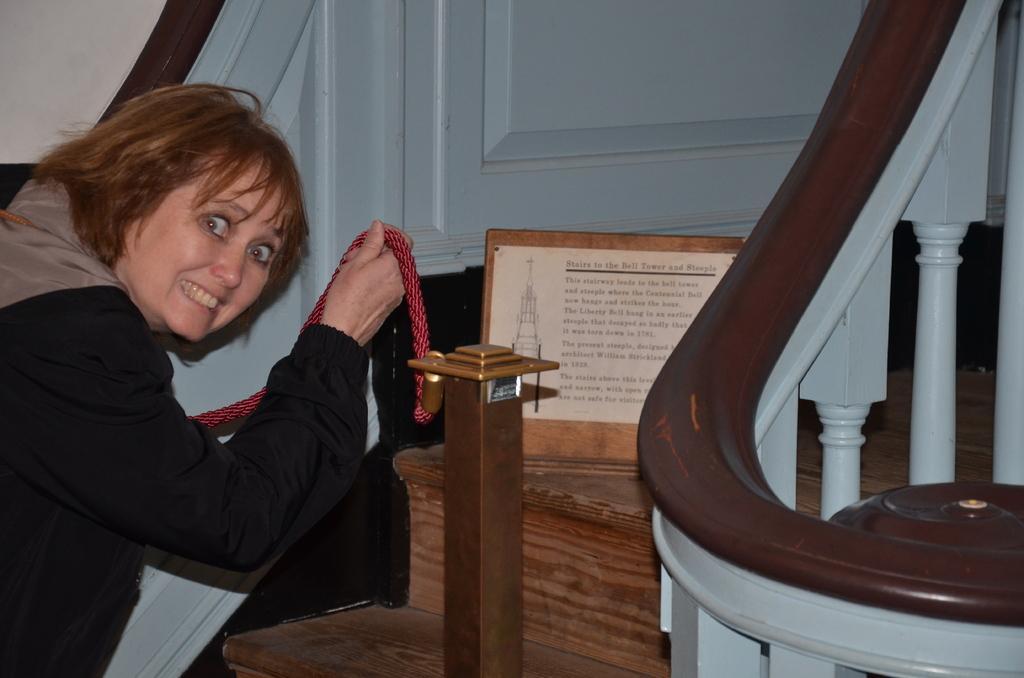How would you summarize this image in a sentence or two? In this image on the left side there is one woman who is holding a rope, and in the background there is a door board and on the right side there are some poles. At the bottom there are wooden stairs. 